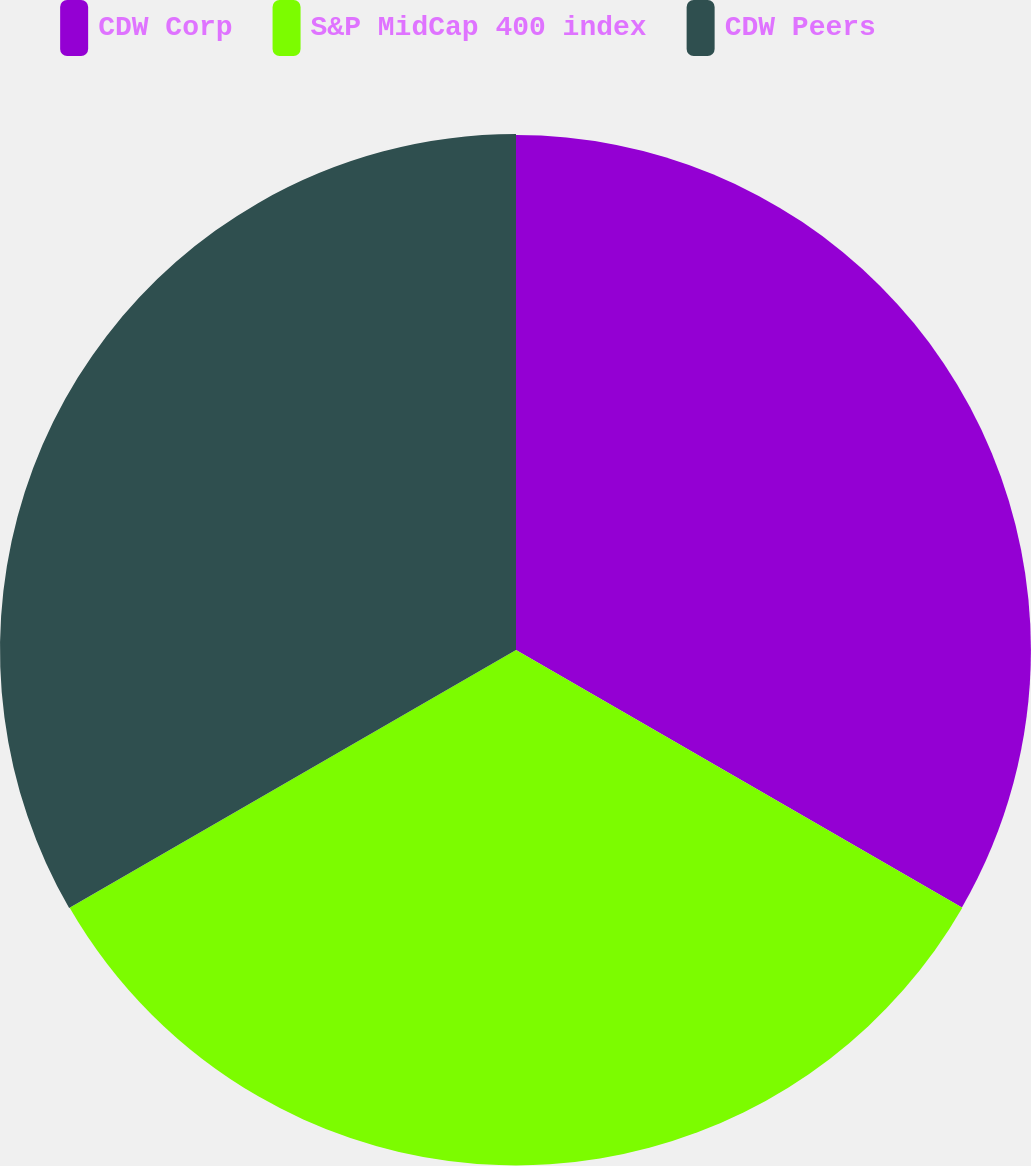Convert chart. <chart><loc_0><loc_0><loc_500><loc_500><pie_chart><fcel>CDW Corp<fcel>S&P MidCap 400 index<fcel>CDW Peers<nl><fcel>33.3%<fcel>33.33%<fcel>33.37%<nl></chart> 